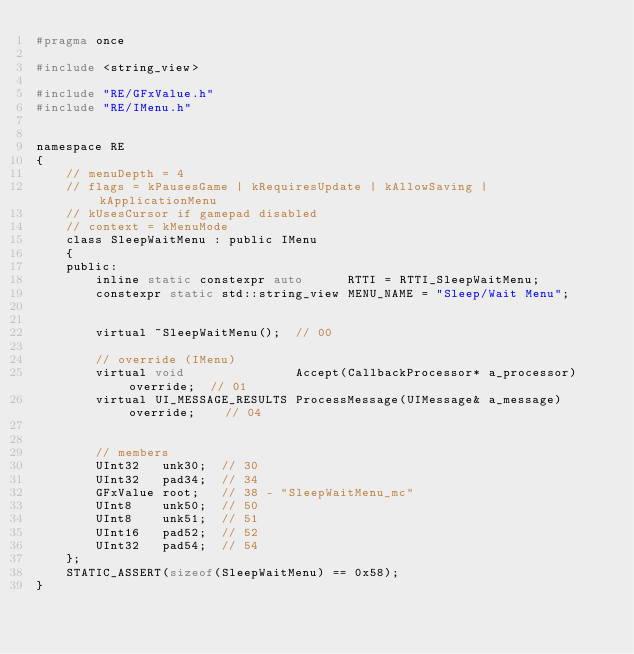Convert code to text. <code><loc_0><loc_0><loc_500><loc_500><_C_>#pragma once

#include <string_view>

#include "RE/GFxValue.h"
#include "RE/IMenu.h"


namespace RE
{
	// menuDepth = 4
	// flags = kPausesGame | kRequiresUpdate | kAllowSaving | kApplicationMenu
	// kUsesCursor if gamepad disabled
	// context = kMenuMode
	class SleepWaitMenu : public IMenu
	{
	public:
		inline static constexpr auto	  RTTI = RTTI_SleepWaitMenu;
		constexpr static std::string_view MENU_NAME = "Sleep/Wait Menu";


		virtual ~SleepWaitMenu();  // 00

		// override (IMenu)
		virtual void			   Accept(CallbackProcessor* a_processor) override;	 // 01
		virtual UI_MESSAGE_RESULTS ProcessMessage(UIMessage& a_message) override;	 // 04


		// members
		UInt32	 unk30;	 // 30
		UInt32	 pad34;	 // 34
		GFxValue root;	 // 38 - "SleepWaitMenu_mc"
		UInt8	 unk50;	 // 50
		UInt8	 unk51;	 // 51
		UInt16	 pad52;	 // 52
		UInt32	 pad54;	 // 54
	};
	STATIC_ASSERT(sizeof(SleepWaitMenu) == 0x58);
}
</code> 